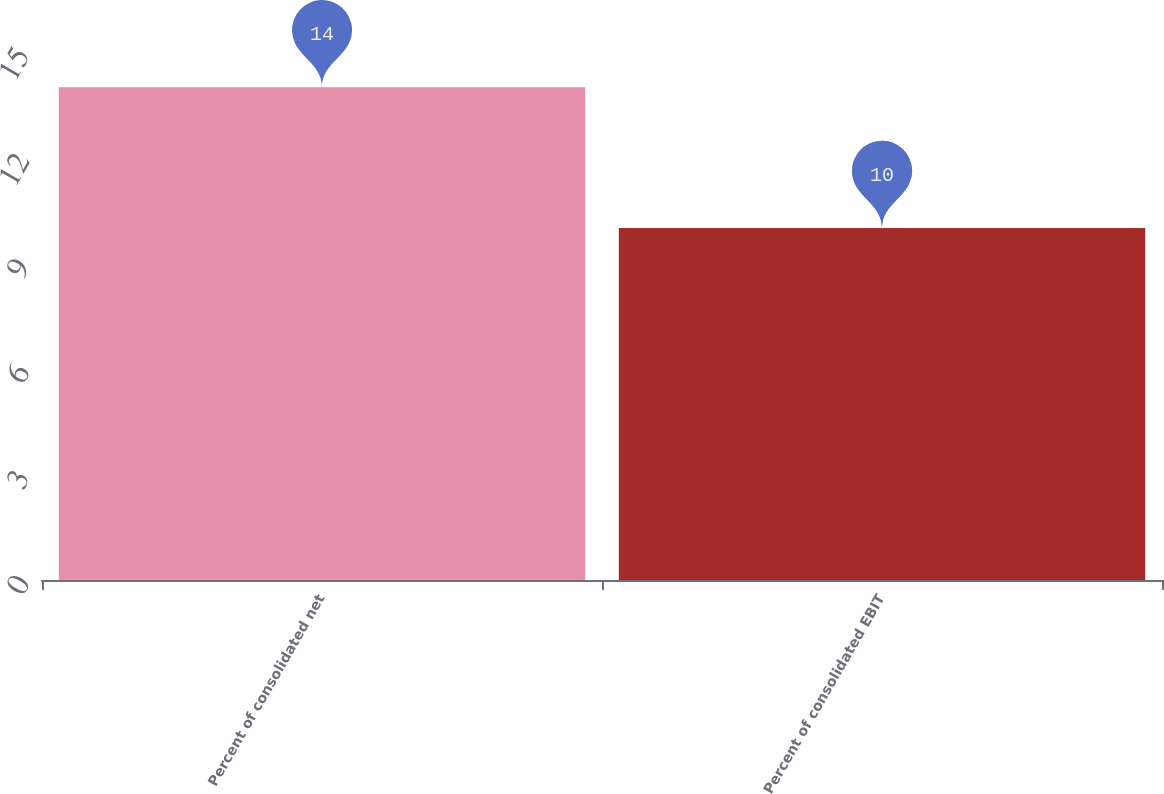<chart> <loc_0><loc_0><loc_500><loc_500><bar_chart><fcel>Percent of consolidated net<fcel>Percent of consolidated EBIT<nl><fcel>14<fcel>10<nl></chart> 